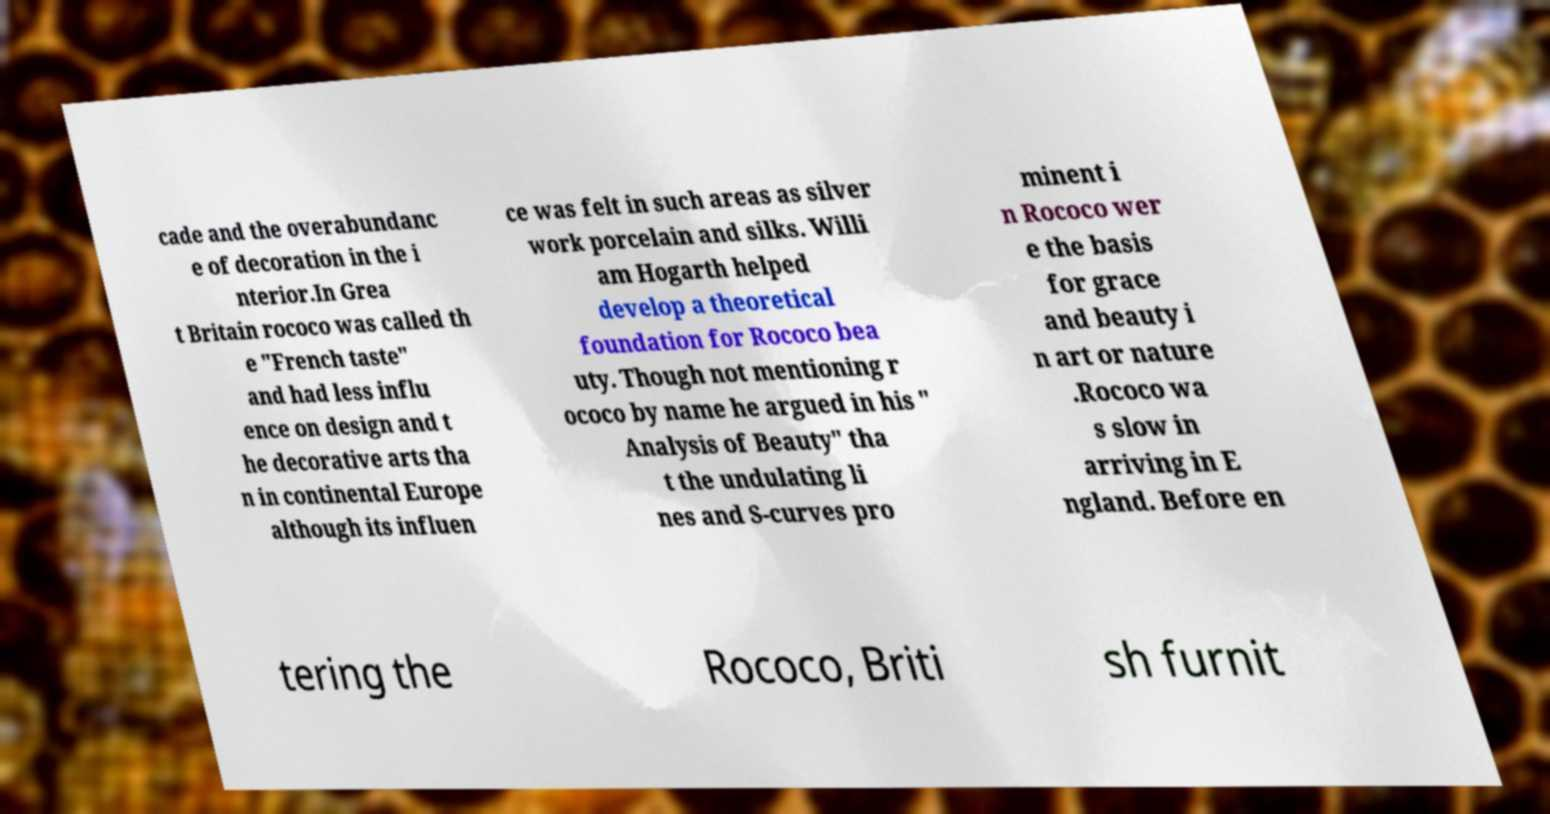Please read and relay the text visible in this image. What does it say? cade and the overabundanc e of decoration in the i nterior.In Grea t Britain rococo was called th e "French taste" and had less influ ence on design and t he decorative arts tha n in continental Europe although its influen ce was felt in such areas as silver work porcelain and silks. Willi am Hogarth helped develop a theoretical foundation for Rococo bea uty. Though not mentioning r ococo by name he argued in his " Analysis of Beauty" tha t the undulating li nes and S-curves pro minent i n Rococo wer e the basis for grace and beauty i n art or nature .Rococo wa s slow in arriving in E ngland. Before en tering the Rococo, Briti sh furnit 